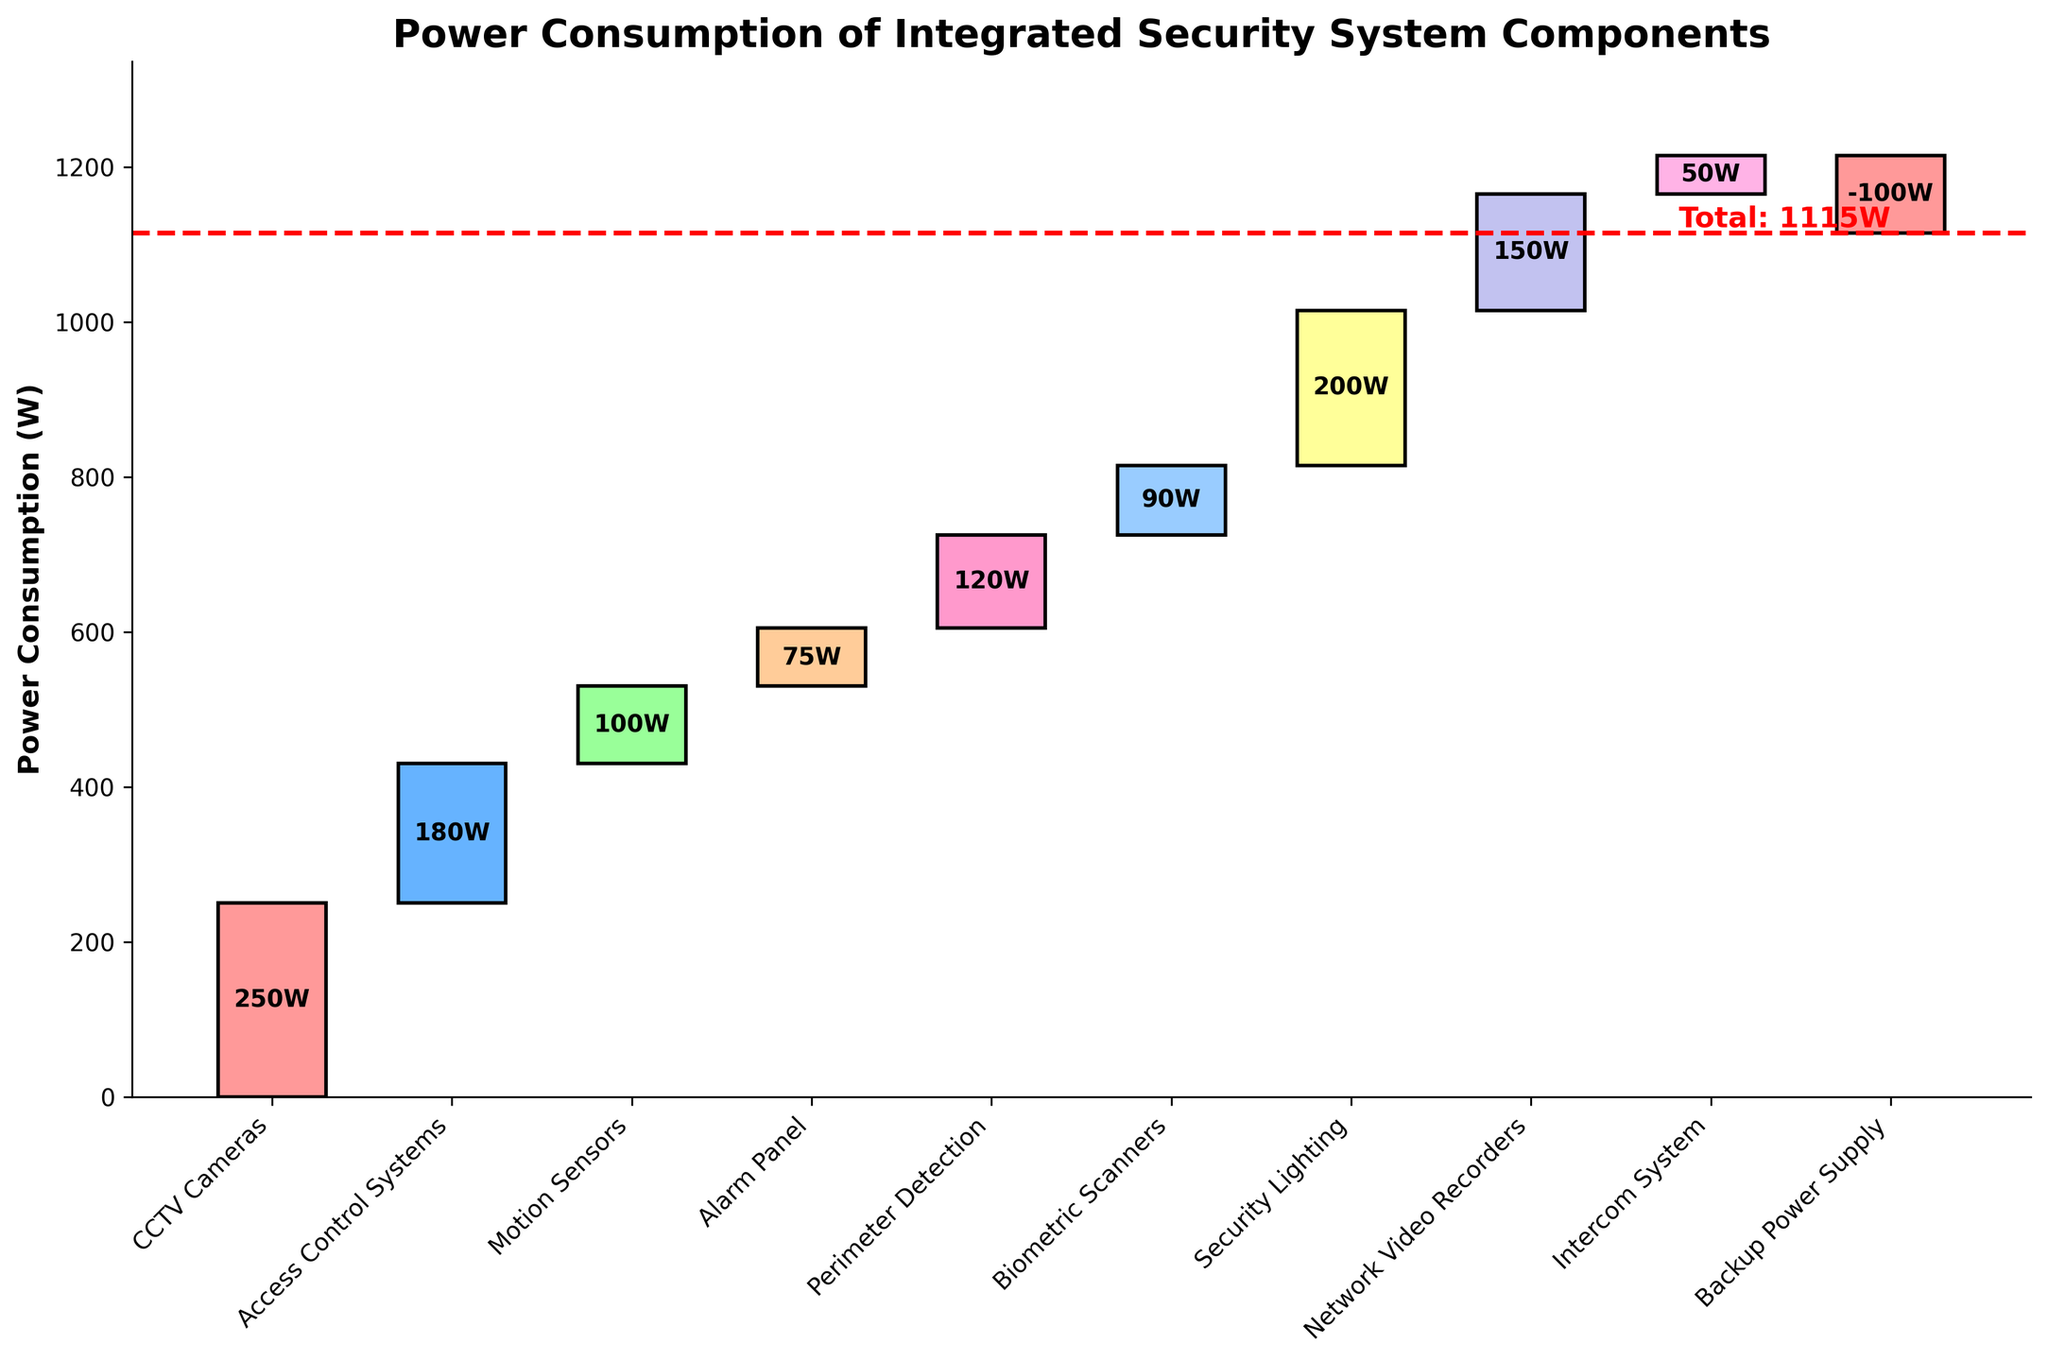What is the title of the figure? The title is usually displayed at the top of the chart, generally in a larger and bolder font compared to the rest of the text.
Answer: Power Consumption of Integrated Security System Components What is the power consumption value of the CCTV Cameras component? The power consumption for each component is labeled on the corresponding bar. The bar for CCTV Cameras shows '250W' in the center of the bar.
Answer: 250W Which component contributes the least to the total power consumption? The smallest bar, indicating the lowest power consumption value, is for the Intercom System, showing '50W'.
Answer: Intercom System What is the total power consumption of the system? The total power consumption is often marked by a horizontal line with an annotation, 'Total: 1115W' near the end of the x-axis.
Answer: 1115W How much power does the Backup Power Supply save? Power savings are indicated by negative values. The bar for Backup Power Supply has a value of '-100W', showing that it reduces consumption by 100W.
Answer: 100W What is the sum of the power consumption for the Motion Sensors and Biometric Scanners? The Motion Sensors consume 100W and the Biometric Scanners 90W. Adding these together gives 100W + 90W = 190W.
Answer: 190W How does the power consumption of Security Lighting compare to that of the Network Video Recorders? Security Lighting has a consumption of 200W, while Network Video Recorders consume 150W. Comparing these, 200W is greater than 150W.
Answer: Security Lighting consumes 50W more than Network Video Recorders Which component has the highest power consumption and what is its value? By looking at the heights of the bars, the highest power consumption is for CCTV Cameras with the value '250W' marked on the bar.
Answer: CCTV Cameras, 250W What is the average power consumption of all components excluding the Backup Power Supply? Sum the power consumption of all other components (250 + 180 + 100 + 75 + 120 + 90 + 200 + 150 + 50 = 1215W). There are 9 components, so the average is 1215W / 9 = 135W.
Answer: 135W 